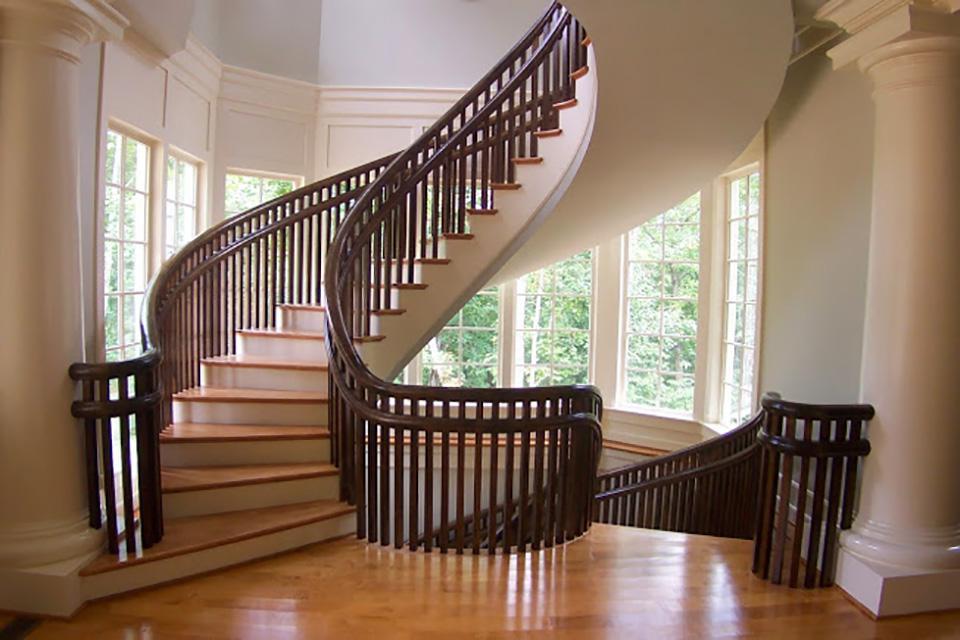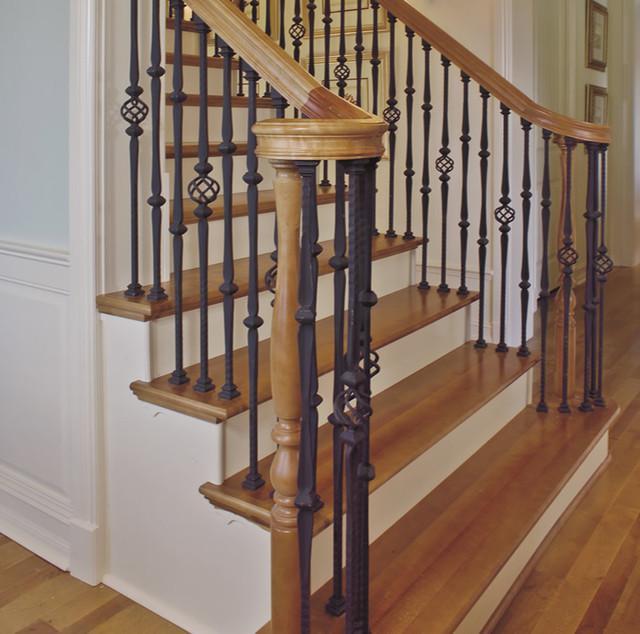The first image is the image on the left, the second image is the image on the right. Considering the images on both sides, is "In at least one image there are white stair covered with brown wood top next to a black metal ball railing." valid? Answer yes or no. Yes. 